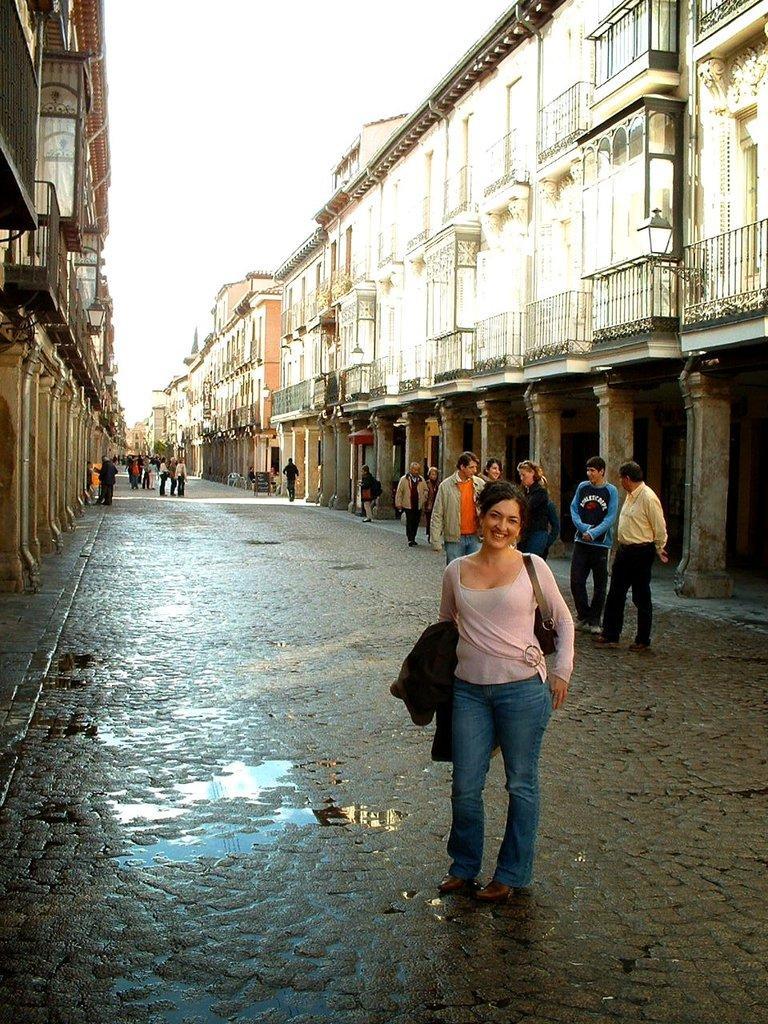Can you describe this image briefly? In this image on the right side and left side there are buildings, and in the center there are a group of people who are walking and one woman is standing and she is wearing a bag and holding a jacket and there is a walkway. At the top there is sky. 